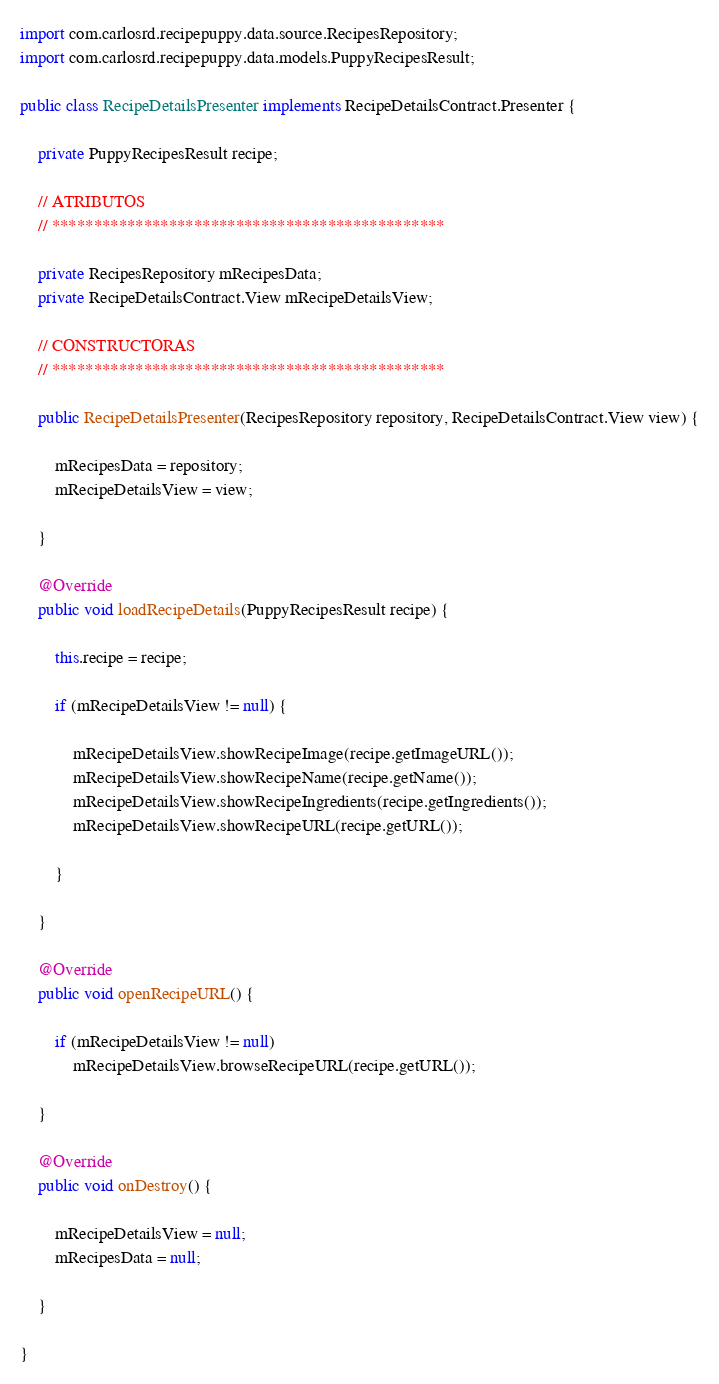Convert code to text. <code><loc_0><loc_0><loc_500><loc_500><_Java_>import com.carlosrd.recipepuppy.data.source.RecipesRepository;
import com.carlosrd.recipepuppy.data.models.PuppyRecipesResult;

public class RecipeDetailsPresenter implements RecipeDetailsContract.Presenter {

    private PuppyRecipesResult recipe;

    // ATRIBUTOS
    // ***********************************************

    private RecipesRepository mRecipesData;
    private RecipeDetailsContract.View mRecipeDetailsView;

    // CONSTRUCTORAS
    // ***********************************************

    public RecipeDetailsPresenter(RecipesRepository repository, RecipeDetailsContract.View view) {

        mRecipesData = repository;
        mRecipeDetailsView = view;

    }

    @Override
    public void loadRecipeDetails(PuppyRecipesResult recipe) {

        this.recipe = recipe;

        if (mRecipeDetailsView != null) {

            mRecipeDetailsView.showRecipeImage(recipe.getImageURL());
            mRecipeDetailsView.showRecipeName(recipe.getName());
            mRecipeDetailsView.showRecipeIngredients(recipe.getIngredients());
            mRecipeDetailsView.showRecipeURL(recipe.getURL());

        }

    }

    @Override
    public void openRecipeURL() {

        if (mRecipeDetailsView != null)
            mRecipeDetailsView.browseRecipeURL(recipe.getURL());

    }

    @Override
    public void onDestroy() {

        mRecipeDetailsView = null;
        mRecipesData = null;

    }

}
</code> 